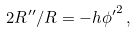Convert formula to latex. <formula><loc_0><loc_0><loc_500><loc_500>2 R ^ { \prime \prime } / R = - h { \phi ^ { \prime } } ^ { 2 } \, ,</formula> 